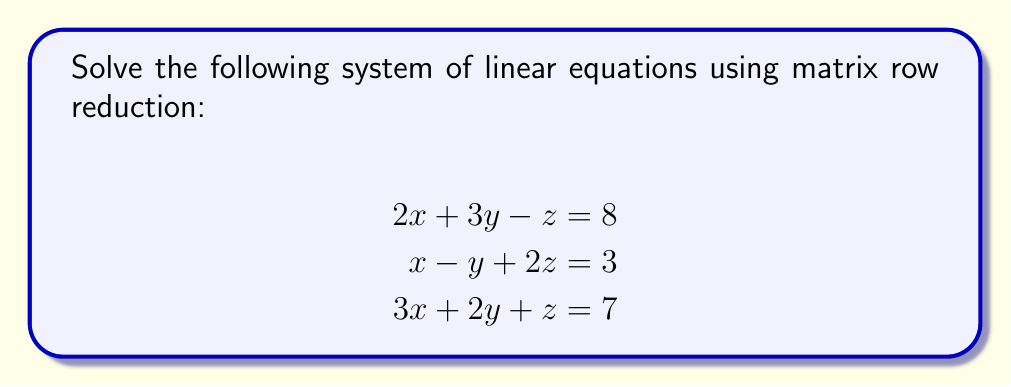Can you answer this question? Let's solve this system using matrix row reduction:

1) First, we'll write the augmented matrix:

$$
\begin{bmatrix}
2 & 3 & -1 & | & 8 \\
1 & -1 & 2 & | & 3 \\
3 & 2 & 1 & | & 7
\end{bmatrix}
$$

2) We'll use $R_1$ as the pivot row. Subtract 2 times $R_1$ from $R_3$:

$$
\begin{bmatrix}
2 & 3 & -1 & | & 8 \\
1 & -1 & 2 & | & 3 \\
0 & -4 & 3 & | & -9
\end{bmatrix}
$$

3) Now, subtract $R_1$ from $R_2$:

$$
\begin{bmatrix}
2 & 3 & -1 & | & 8 \\
0 & -4 & 3 & | & -5 \\
0 & -4 & 3 & | & -9
\end{bmatrix}
$$

4) Subtract $R_2$ from $R_3$:

$$
\begin{bmatrix}
2 & 3 & -1 & | & 8 \\
0 & -4 & 3 & | & -5 \\
0 & 0 & 0 & | & -4
\end{bmatrix}
$$

5) The last row indicates an inconsistency (0 = -4), so the system has no solution.
Answer: The system has no solution. 